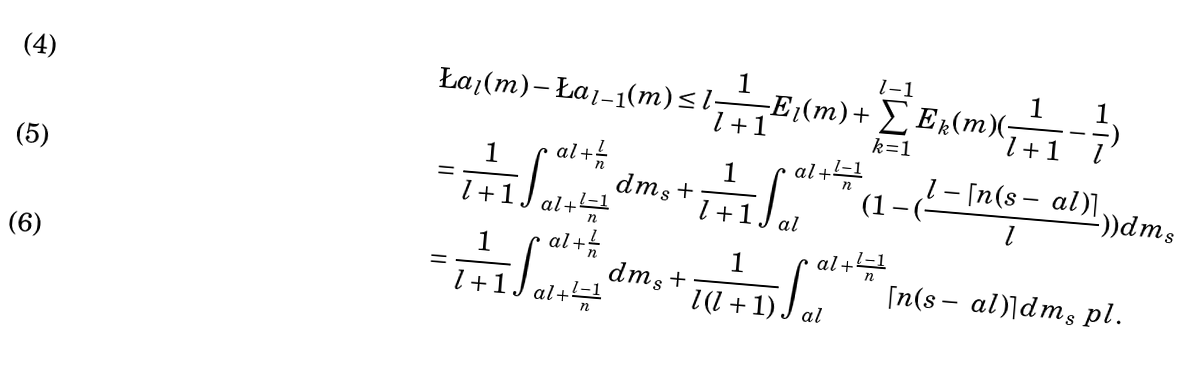<formula> <loc_0><loc_0><loc_500><loc_500>& \L a _ { l } ( m ) - \L a _ { l - 1 } ( m ) \leq l \frac { 1 } { l + 1 } E _ { l } ( m ) + \sum _ { k = 1 } ^ { l - 1 } E _ { k } ( m ) ( \frac { 1 } { l + 1 } - \frac { 1 } { l } ) \\ & = \frac { 1 } { l + 1 } \int _ { \ a l + \frac { l - 1 } { n } } ^ { \ a l + \frac { l } { n } } d m _ { s } + \frac { 1 } { l + 1 } \int _ { \ a l } ^ { \ a l + \frac { l - 1 } { n } } ( 1 - ( \frac { l - \lceil n ( s - \ a l ) \rceil } { l } ) ) d m _ { s } \\ & = \frac { 1 } { l + 1 } \int _ { \ a l + \frac { l - 1 } { n } } ^ { \ a l + \frac { l } { n } } d m _ { s } + \frac { 1 } { l ( l + 1 ) } \int _ { \ a l } ^ { \ a l + \frac { l - 1 } { n } } \lceil n ( s - \ a l ) \rceil d m _ { s } \ p l .</formula> 